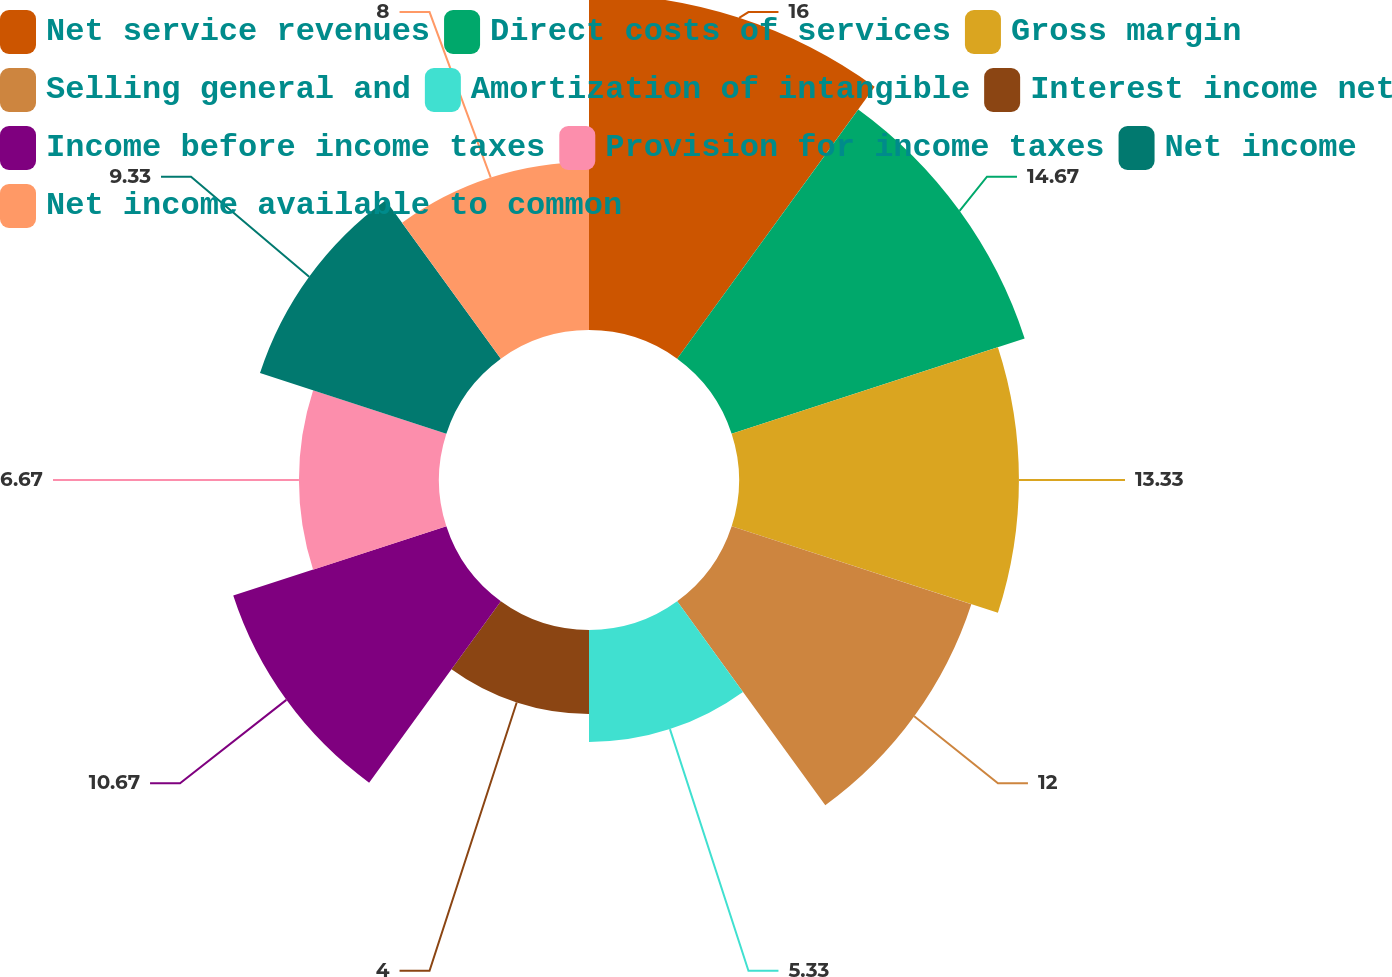Convert chart. <chart><loc_0><loc_0><loc_500><loc_500><pie_chart><fcel>Net service revenues<fcel>Direct costs of services<fcel>Gross margin<fcel>Selling general and<fcel>Amortization of intangible<fcel>Interest income net<fcel>Income before income taxes<fcel>Provision for income taxes<fcel>Net income<fcel>Net income available to common<nl><fcel>16.0%<fcel>14.67%<fcel>13.33%<fcel>12.0%<fcel>5.33%<fcel>4.0%<fcel>10.67%<fcel>6.67%<fcel>9.33%<fcel>8.0%<nl></chart> 